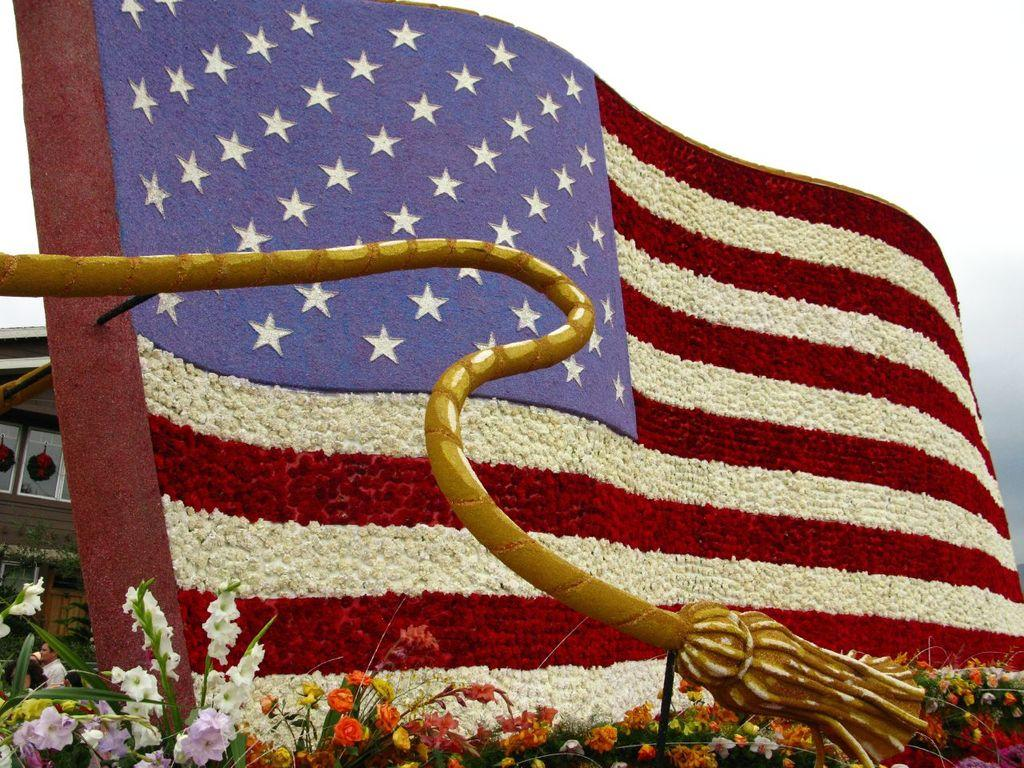What is the flag in the image made of? The flag in the image is made of flowers. What can be seen in the foreground of the image? Flower bouquets are present in the foreground of the image. What structure is located on the left side of the image? There is a house on the left side of the image. How would you describe the sky in the image? The sky is cloudy in the image. What type of pot is visible in the image? There is no pot present in the image. How much salt is sprinkled on the flower bouquets in the image? There is no salt present in the image, as it is a picture of flowers and a flower-made flag. 